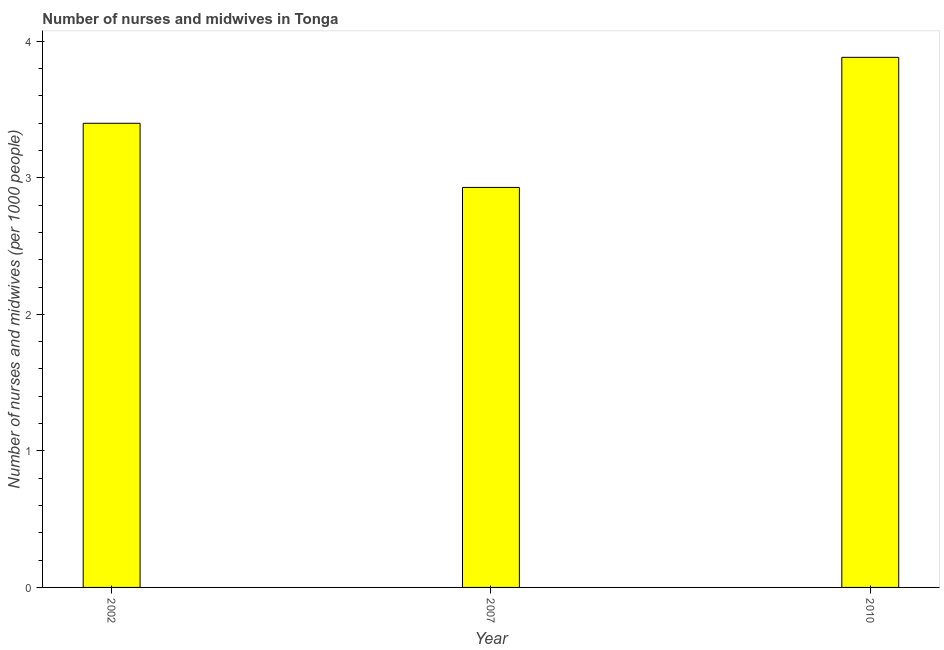Does the graph contain any zero values?
Your answer should be compact. No. Does the graph contain grids?
Offer a terse response. No. What is the title of the graph?
Your answer should be very brief. Number of nurses and midwives in Tonga. What is the label or title of the Y-axis?
Give a very brief answer. Number of nurses and midwives (per 1000 people). What is the number of nurses and midwives in 2010?
Ensure brevity in your answer.  3.88. Across all years, what is the maximum number of nurses and midwives?
Give a very brief answer. 3.88. Across all years, what is the minimum number of nurses and midwives?
Your response must be concise. 2.93. In which year was the number of nurses and midwives maximum?
Give a very brief answer. 2010. In which year was the number of nurses and midwives minimum?
Your response must be concise. 2007. What is the sum of the number of nurses and midwives?
Your answer should be very brief. 10.21. What is the difference between the number of nurses and midwives in 2002 and 2007?
Provide a short and direct response. 0.47. What is the average number of nurses and midwives per year?
Your response must be concise. 3.4. What is the median number of nurses and midwives?
Offer a very short reply. 3.4. In how many years, is the number of nurses and midwives greater than 2.8 ?
Your response must be concise. 3. Do a majority of the years between 2002 and 2010 (inclusive) have number of nurses and midwives greater than 3.4 ?
Offer a very short reply. No. What is the ratio of the number of nurses and midwives in 2007 to that in 2010?
Provide a short and direct response. 0.76. Is the difference between the number of nurses and midwives in 2002 and 2007 greater than the difference between any two years?
Ensure brevity in your answer.  No. What is the difference between the highest and the second highest number of nurses and midwives?
Ensure brevity in your answer.  0.48. Is the sum of the number of nurses and midwives in 2002 and 2010 greater than the maximum number of nurses and midwives across all years?
Provide a succinct answer. Yes. What is the difference between the highest and the lowest number of nurses and midwives?
Keep it short and to the point. 0.95. What is the difference between two consecutive major ticks on the Y-axis?
Provide a succinct answer. 1. Are the values on the major ticks of Y-axis written in scientific E-notation?
Provide a short and direct response. No. What is the Number of nurses and midwives (per 1000 people) of 2002?
Offer a terse response. 3.4. What is the Number of nurses and midwives (per 1000 people) in 2007?
Offer a terse response. 2.93. What is the Number of nurses and midwives (per 1000 people) of 2010?
Offer a very short reply. 3.88. What is the difference between the Number of nurses and midwives (per 1000 people) in 2002 and 2007?
Your answer should be compact. 0.47. What is the difference between the Number of nurses and midwives (per 1000 people) in 2002 and 2010?
Offer a very short reply. -0.48. What is the difference between the Number of nurses and midwives (per 1000 people) in 2007 and 2010?
Your answer should be compact. -0.95. What is the ratio of the Number of nurses and midwives (per 1000 people) in 2002 to that in 2007?
Offer a very short reply. 1.16. What is the ratio of the Number of nurses and midwives (per 1000 people) in 2002 to that in 2010?
Your answer should be very brief. 0.88. What is the ratio of the Number of nurses and midwives (per 1000 people) in 2007 to that in 2010?
Ensure brevity in your answer.  0.76. 